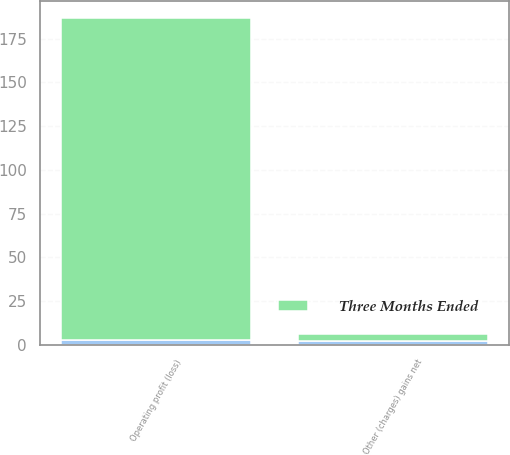<chart> <loc_0><loc_0><loc_500><loc_500><stacked_bar_chart><ecel><fcel>Other (charges) gains net<fcel>Operating profit (loss)<nl><fcel>Three Months Ended<fcel>4<fcel>184<nl><fcel>nan<fcel>2<fcel>3<nl></chart> 